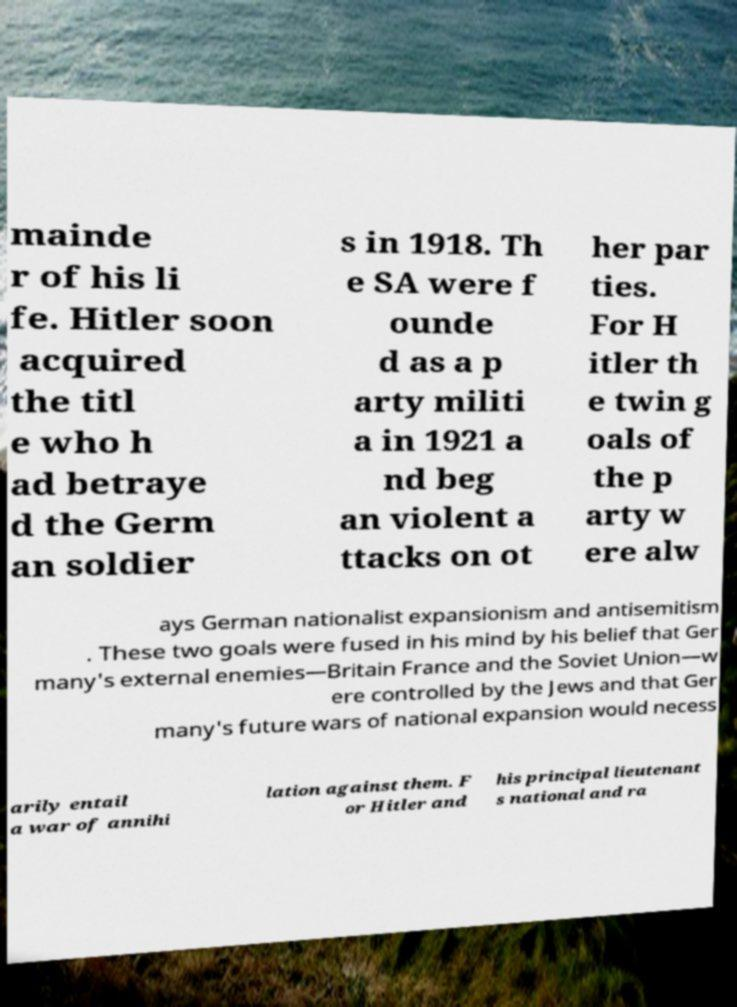I need the written content from this picture converted into text. Can you do that? mainde r of his li fe. Hitler soon acquired the titl e who h ad betraye d the Germ an soldier s in 1918. Th e SA were f ounde d as a p arty militi a in 1921 a nd beg an violent a ttacks on ot her par ties. For H itler th e twin g oals of the p arty w ere alw ays German nationalist expansionism and antisemitism . These two goals were fused in his mind by his belief that Ger many's external enemies—Britain France and the Soviet Union—w ere controlled by the Jews and that Ger many's future wars of national expansion would necess arily entail a war of annihi lation against them. F or Hitler and his principal lieutenant s national and ra 